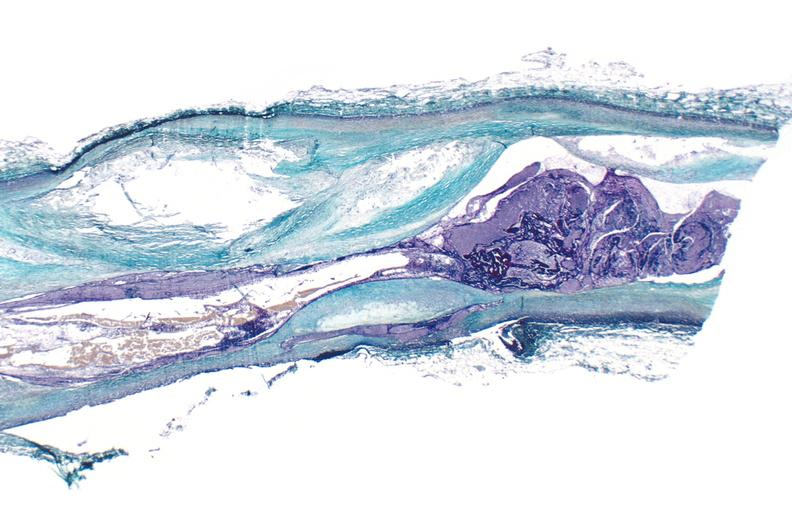where is this?
Answer the question using a single word or phrase. Urinary 